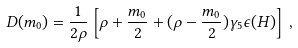Convert formula to latex. <formula><loc_0><loc_0><loc_500><loc_500>D ( m _ { 0 } ) = \frac { 1 } { 2 \rho } \left [ \rho + \frac { m _ { 0 } } { 2 } + ( \rho - \frac { m _ { 0 } } { 2 } ) \gamma _ { 5 } \epsilon ( H ) \right ] \, ,</formula> 